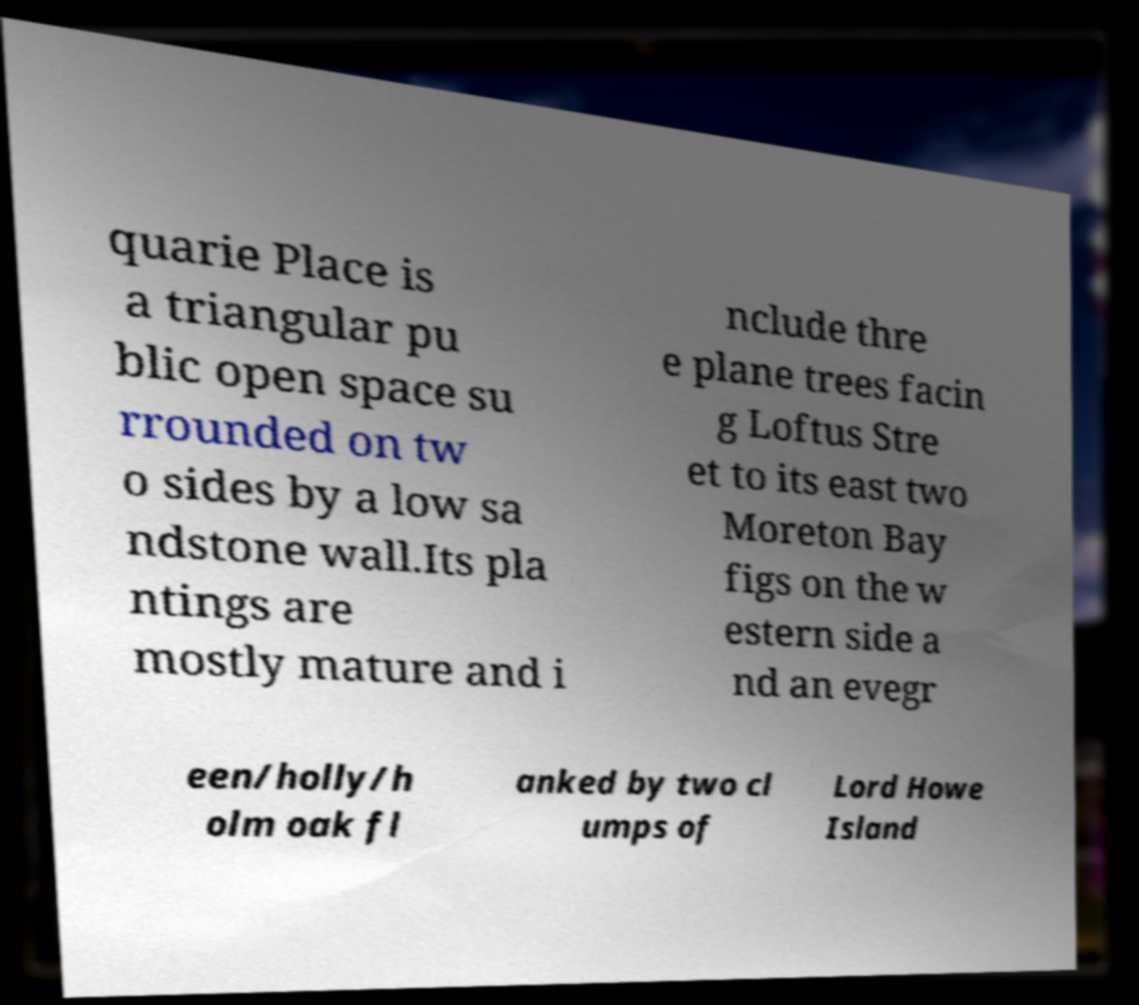Please identify and transcribe the text found in this image. quarie Place is a triangular pu blic open space su rrounded on tw o sides by a low sa ndstone wall.Its pla ntings are mostly mature and i nclude thre e plane trees facin g Loftus Stre et to its east two Moreton Bay figs on the w estern side a nd an evegr een/holly/h olm oak fl anked by two cl umps of Lord Howe Island 